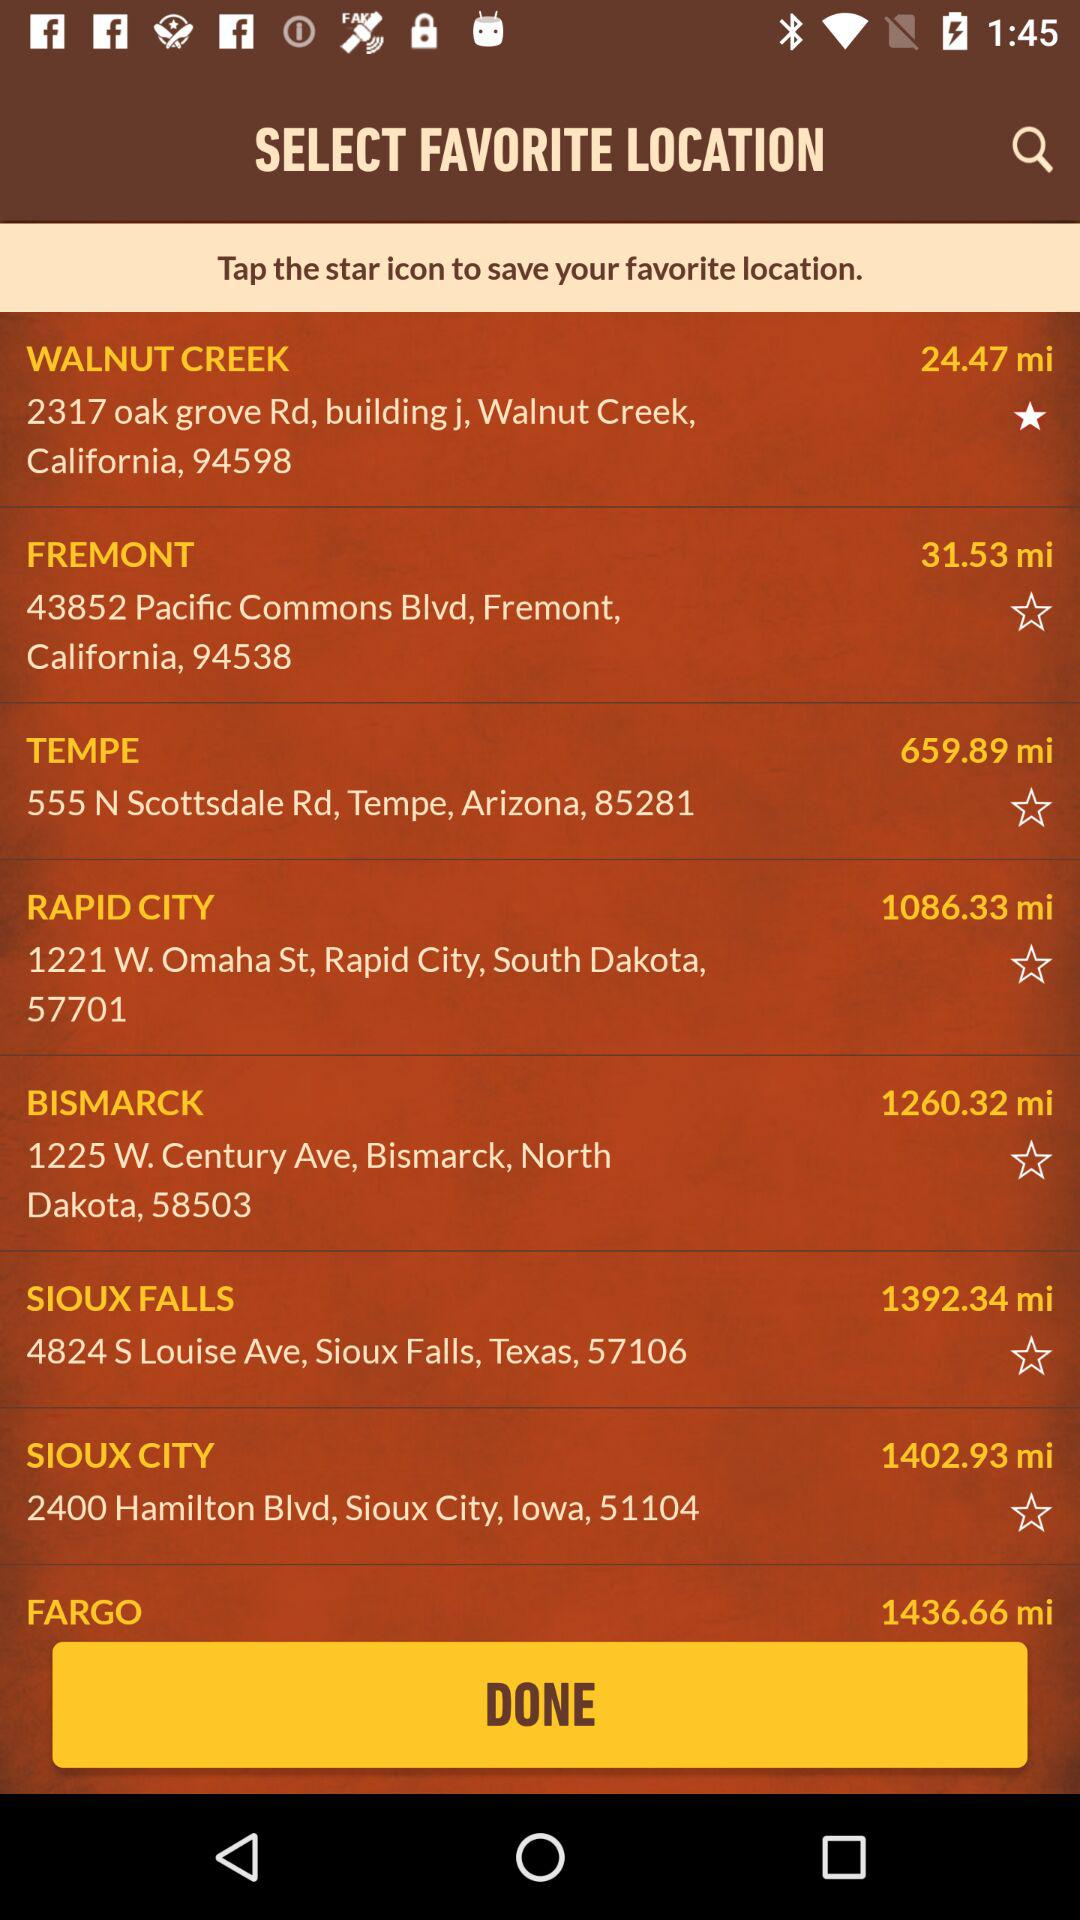Which icon to tap to save a favorite location? Tap the star icon to save a favorite location. 